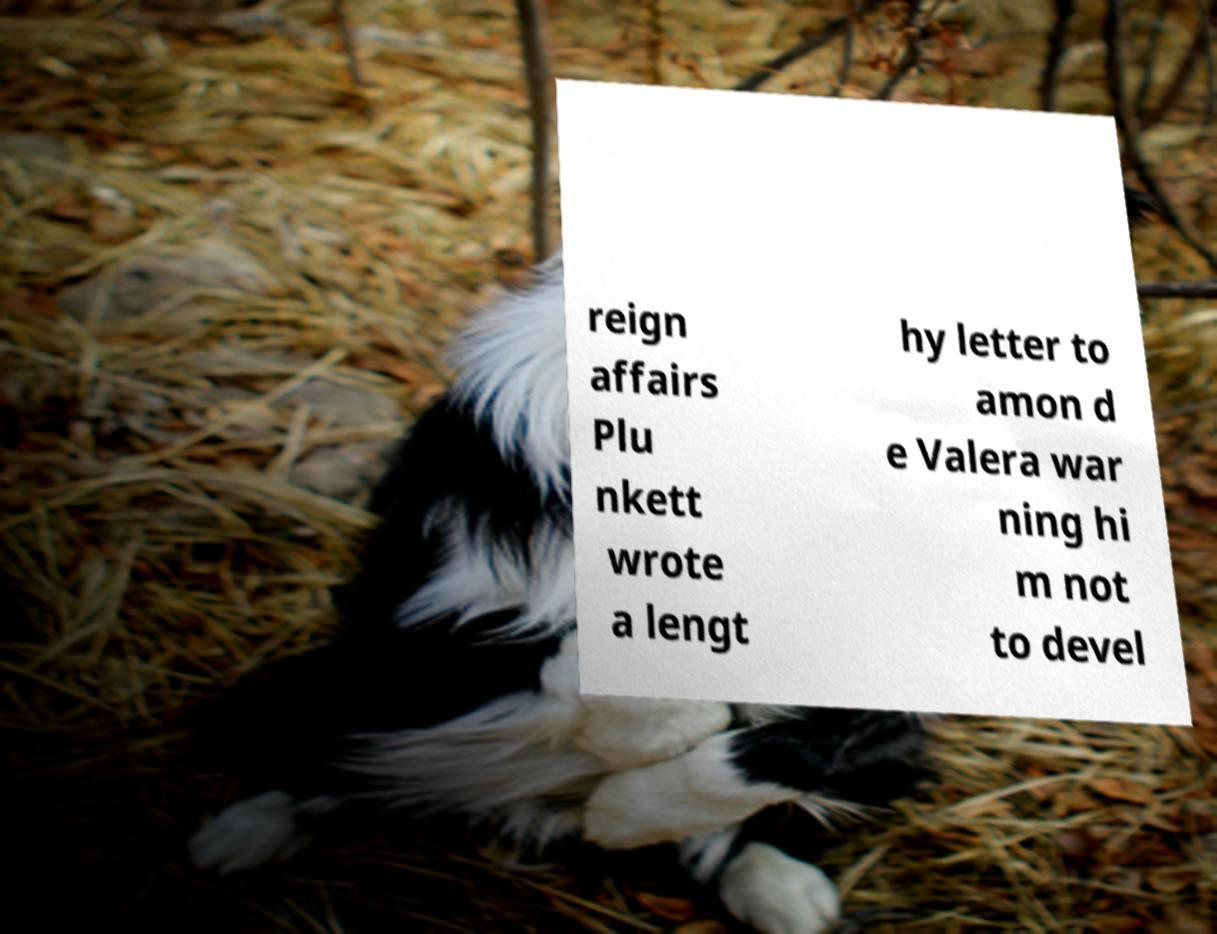For documentation purposes, I need the text within this image transcribed. Could you provide that? reign affairs Plu nkett wrote a lengt hy letter to amon d e Valera war ning hi m not to devel 